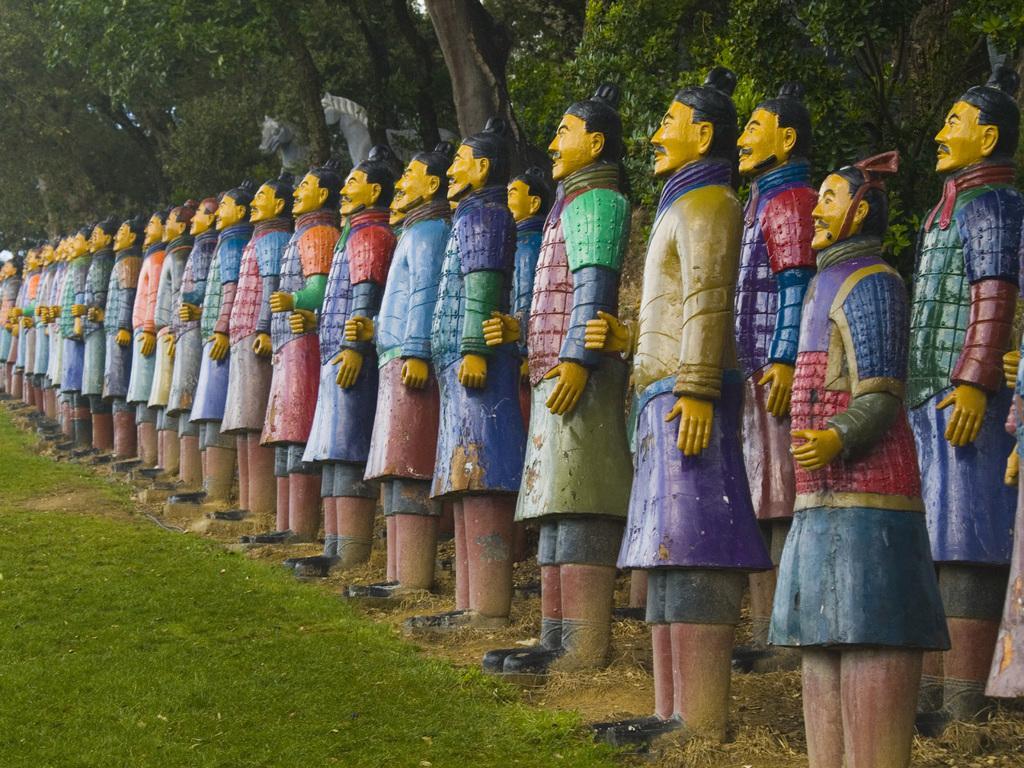How would you summarize this image in a sentence or two? In the picture I can see sculptures of men. I can also see the grass. In the background I can see trees and some other objects. 